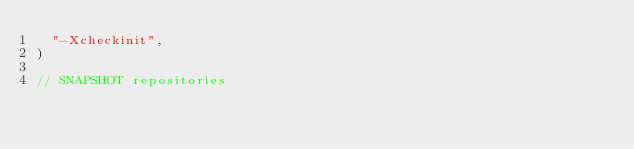Convert code to text. <code><loc_0><loc_0><loc_500><loc_500><_Scala_>  "-Xcheckinit",
)

// SNAPSHOT repositories</code> 